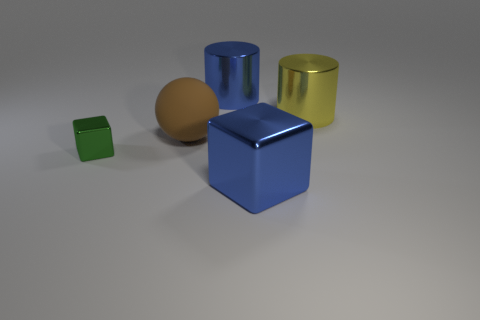Are there any other things that are the same size as the green thing?
Provide a short and direct response. No. What size is the metallic object left of the shiny cylinder left of the big blue metal block?
Offer a terse response. Small. What number of other things are the same color as the small cube?
Your answer should be very brief. 0. What is the material of the green block?
Offer a terse response. Metal. Is there a yellow object?
Offer a very short reply. Yes. Are there the same number of big blue metallic objects in front of the big blue cube and blue metallic objects?
Provide a succinct answer. No. Are there any other things that are the same material as the yellow object?
Provide a short and direct response. Yes. How many big objects are either yellow shiny objects or metal objects?
Your answer should be compact. 3. There is a thing that is the same color as the big metallic block; what is its shape?
Your answer should be very brief. Cylinder. Is the material of the large blue object in front of the tiny green shiny cube the same as the small thing?
Make the answer very short. Yes. 